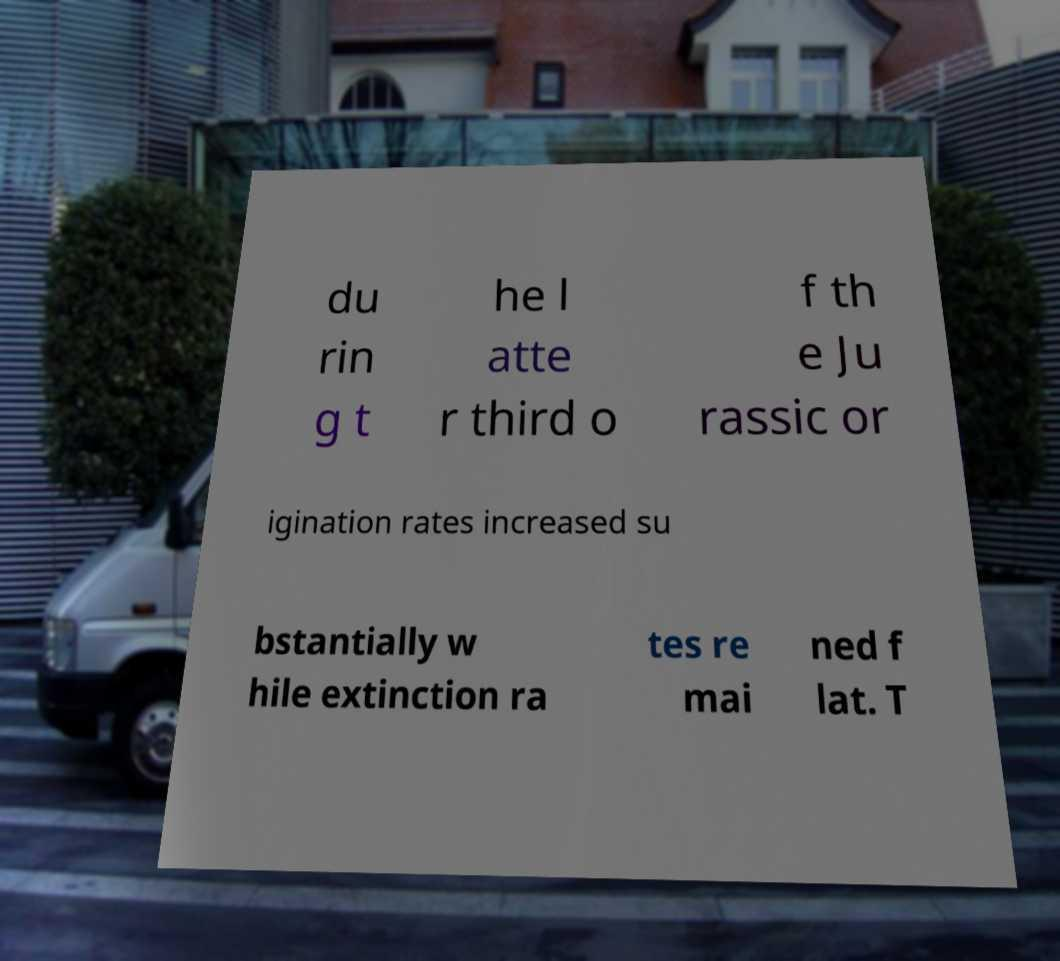What messages or text are displayed in this image? I need them in a readable, typed format. du rin g t he l atte r third o f th e Ju rassic or igination rates increased su bstantially w hile extinction ra tes re mai ned f lat. T 